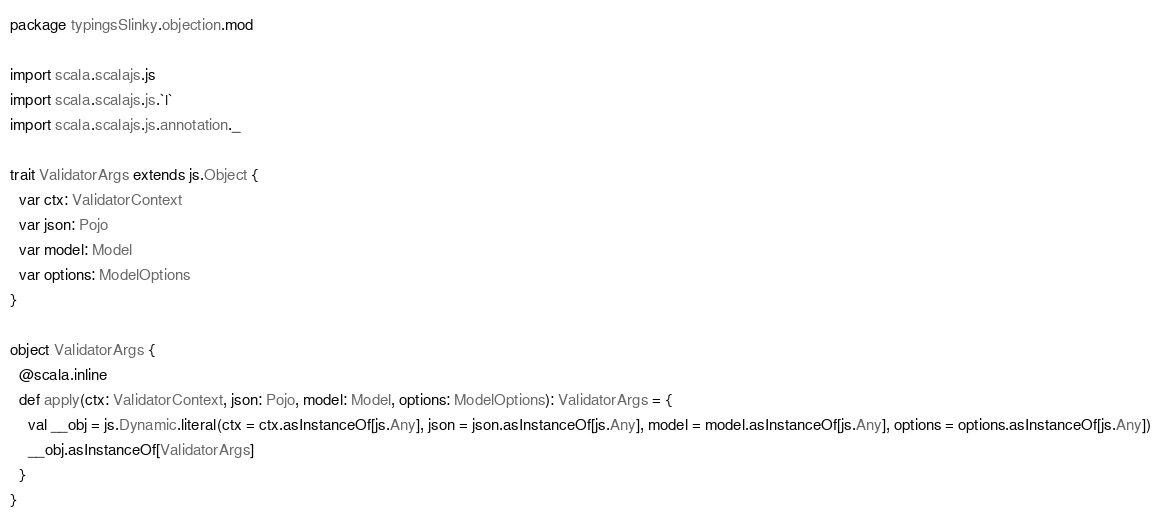Convert code to text. <code><loc_0><loc_0><loc_500><loc_500><_Scala_>package typingsSlinky.objection.mod

import scala.scalajs.js
import scala.scalajs.js.`|`
import scala.scalajs.js.annotation._

trait ValidatorArgs extends js.Object {
  var ctx: ValidatorContext
  var json: Pojo
  var model: Model
  var options: ModelOptions
}

object ValidatorArgs {
  @scala.inline
  def apply(ctx: ValidatorContext, json: Pojo, model: Model, options: ModelOptions): ValidatorArgs = {
    val __obj = js.Dynamic.literal(ctx = ctx.asInstanceOf[js.Any], json = json.asInstanceOf[js.Any], model = model.asInstanceOf[js.Any], options = options.asInstanceOf[js.Any])
    __obj.asInstanceOf[ValidatorArgs]
  }
}

</code> 